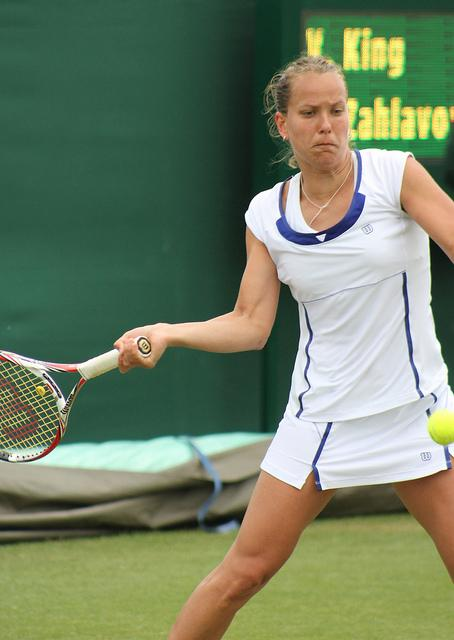What shot is this player making? forehand 